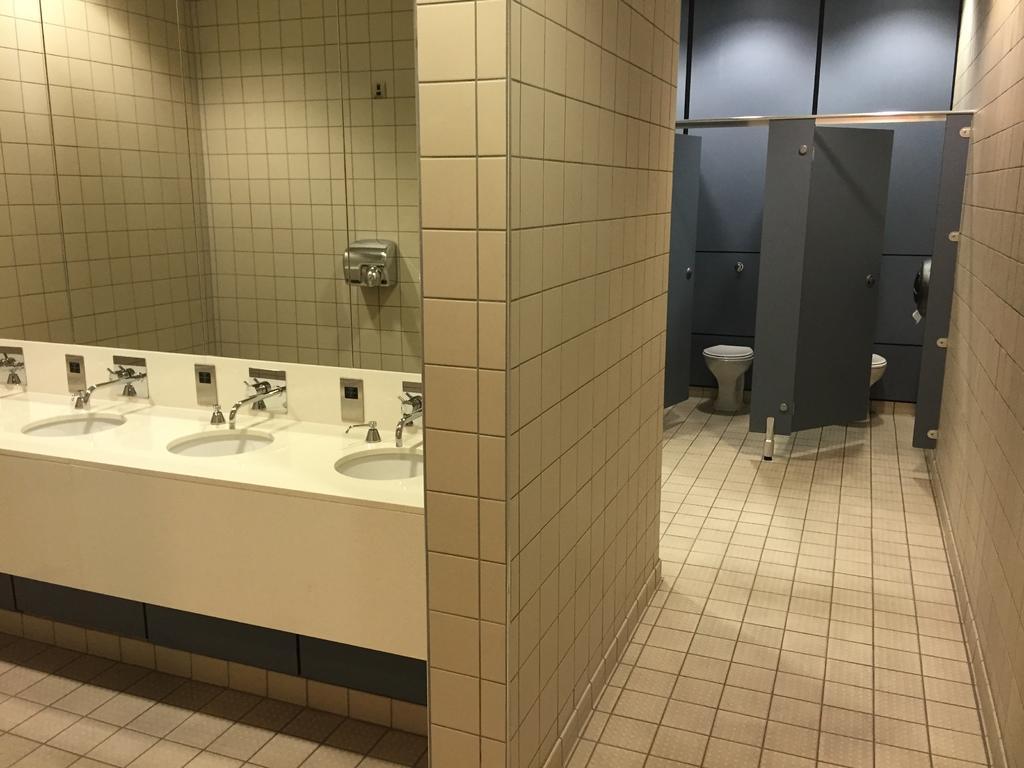Could you give a brief overview of what you see in this image? In this picture I can see sinks, taps, toilet seats and there are doors. 